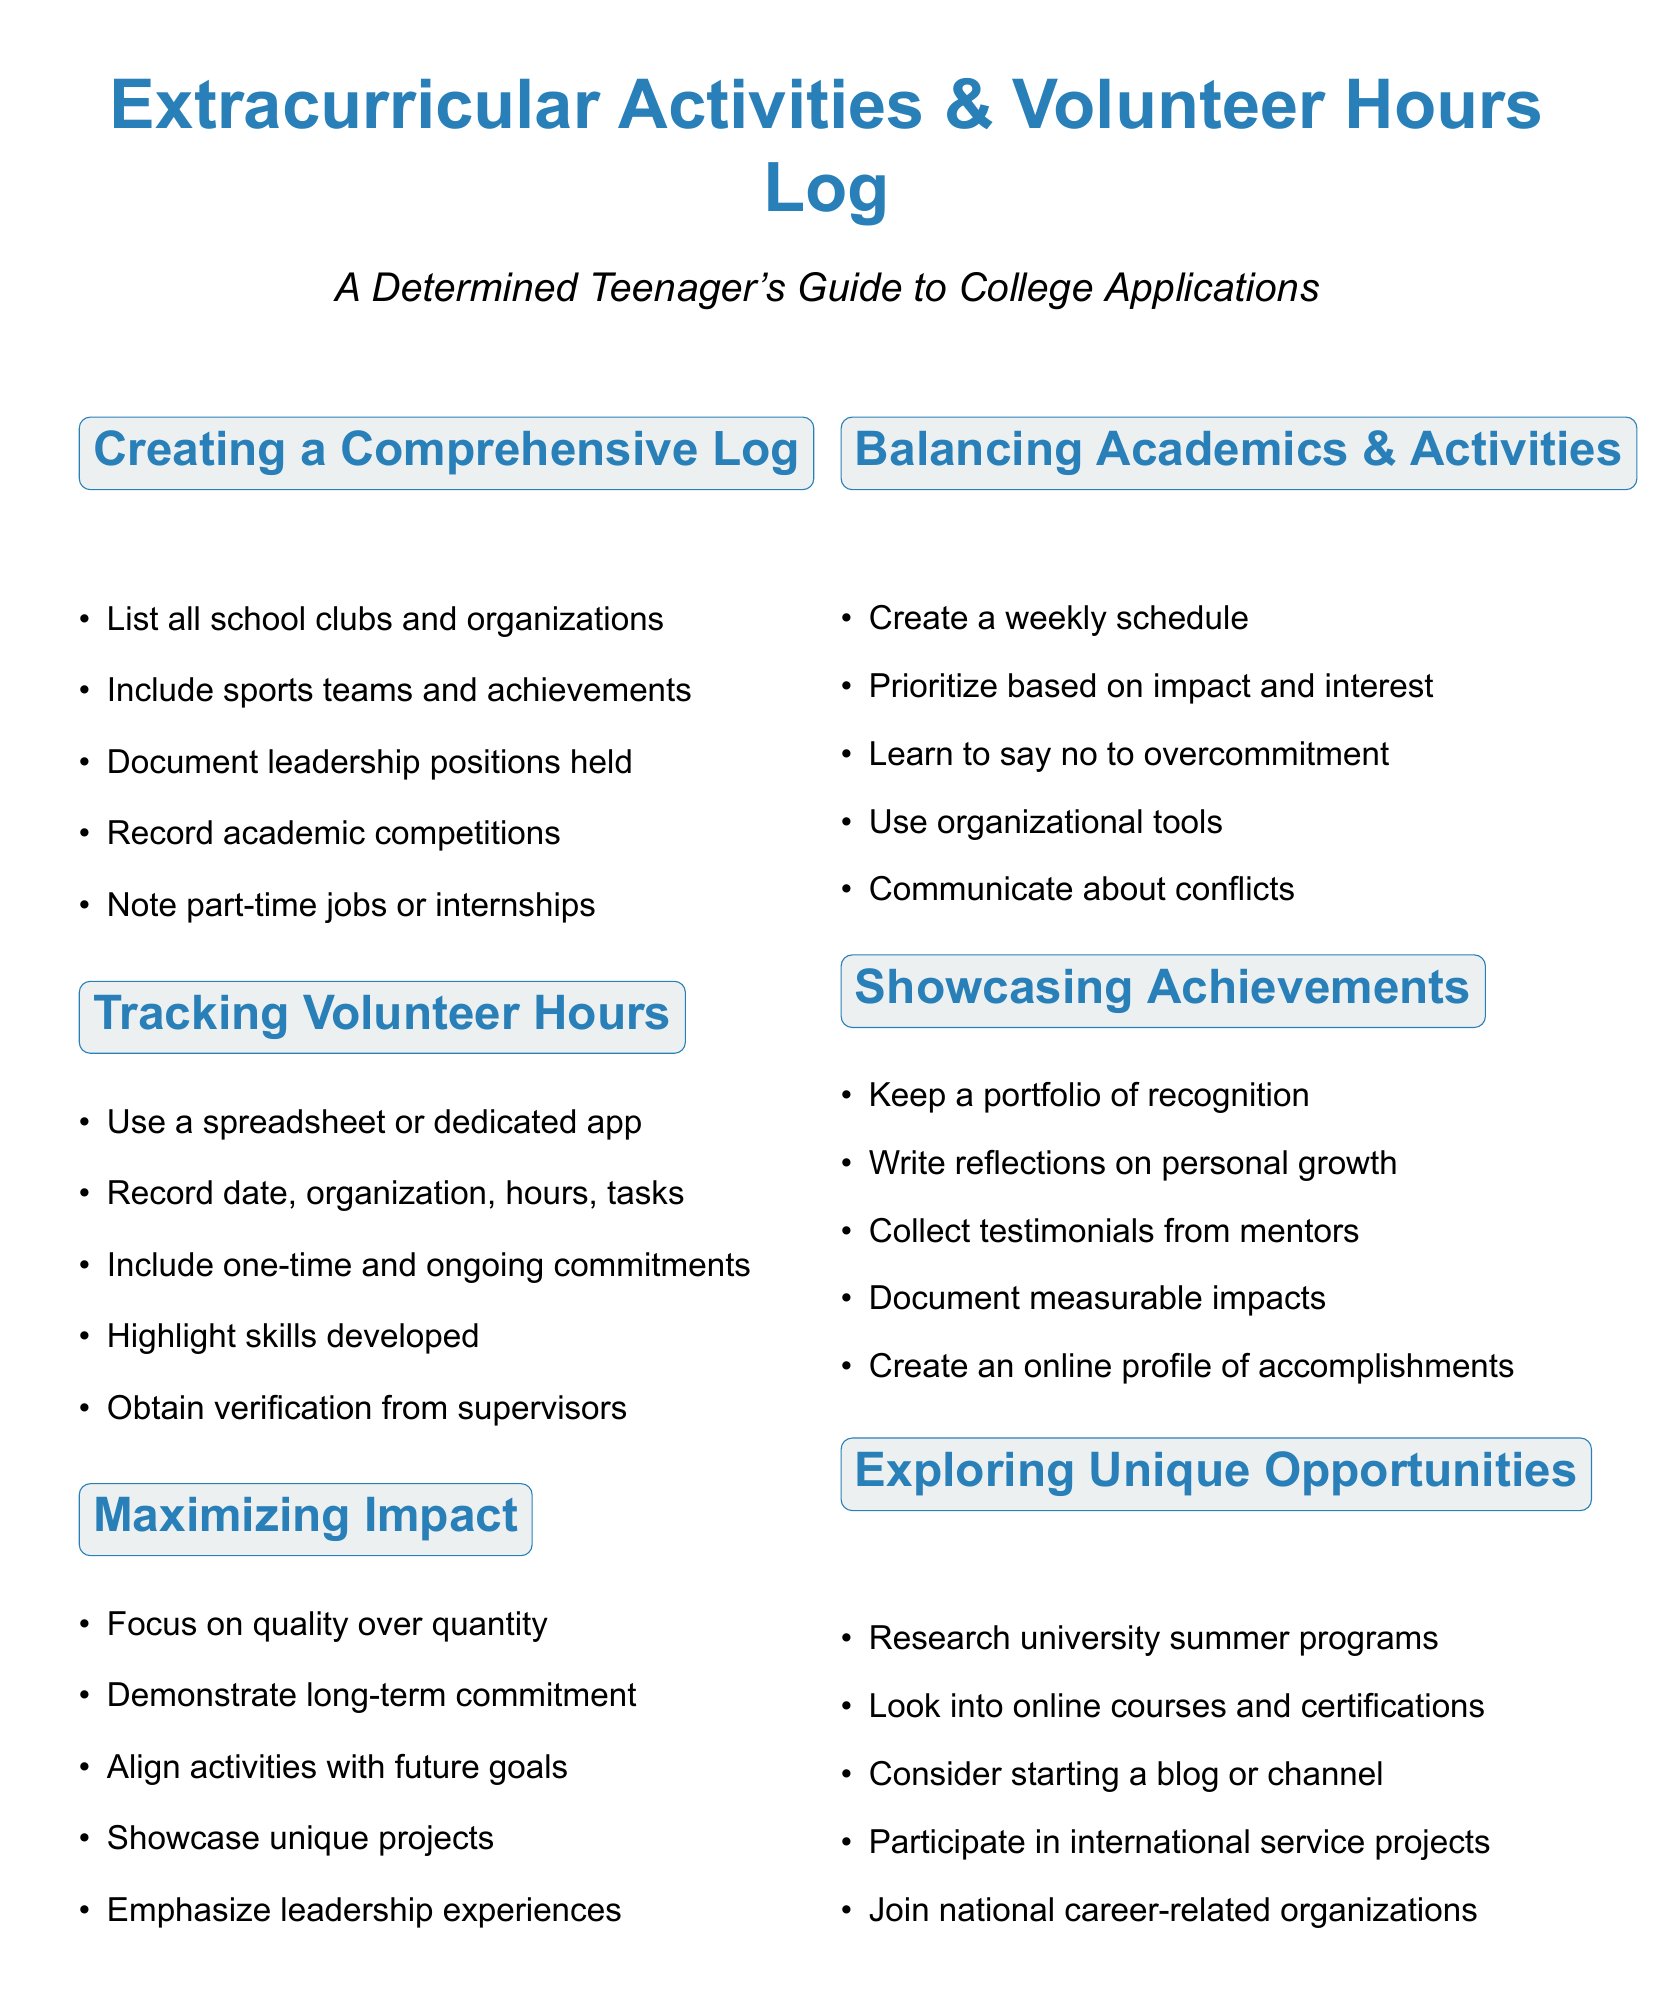What is included in the extracurricular activities log? The log should list all school clubs, sports, leadership positions, competitions, and jobs.
Answer: Clubs, sports, leadership positions, competitions, jobs What tool can be used to track volunteer hours? A spreadsheet or dedicated app like Track It Forward or Givepulse can track volunteer hours.
Answer: Spreadsheet or app How should volunteer hours be documented? Document the date, organization, hours worked, and a description of tasks performed.
Answer: Date, organization, hours, tasks What is one way to showcase achievements? Keep a portfolio of certificates, awards, and recognition to showcase achievements.
Answer: Portfolio of certificates What is emphasized for college applications regarding activities? Focus on the quality of activities rather than the quantity to make a stronger application.
Answer: Quality over quantity What should you do to balance academics and extracurriculars? Create a weekly schedule to manage time effectively.
Answer: Create a weekly schedule What type of opportunities should you explore for extracurricular activities? Explore unique opportunities such as summer programs, online courses, or starting a blog.
Answer: Unique opportunities What is highlighted through volunteer work? Skills developed through volunteer work should be highlighted in applications.
Answer: Skills developed What do you need to obtain for verification of volunteer work? Obtain supervisor signatures or letters of recommendation for verification.
Answer: Supervisor signatures 